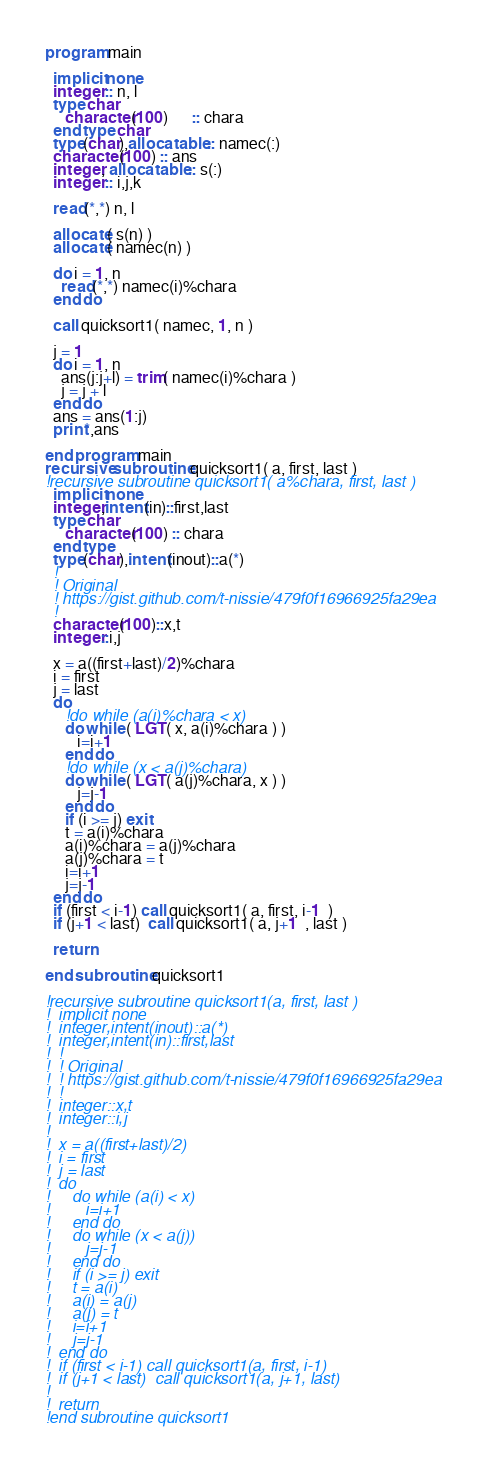<code> <loc_0><loc_0><loc_500><loc_500><_FORTRAN_>program main
  
  implicit none
  integer :: n, l
  type char
     character(100)      :: chara
  end type char
  type(char),allocatable :: namec(:)
  character(100) :: ans
  integer, allocatable :: s(:)
  integer :: i,j,k
  
  read(*,*) n, l

  allocate( s(n) )
  allocate( namec(n) )

  do i = 1, n
    read(*,*) namec(i)%chara
  end do

  call quicksort1( namec, 1, n ) 
  
  j = 1
  do i = 1, n
    ans(j:j+l) = trim( namec(i)%chara )
    j = j + l 
  end do
  ans = ans(1:j)
  print*,ans

end program main
recursive subroutine quicksort1( a, first, last )
!recursive subroutine quicksort1( a%chara, first, last )
  implicit none
  integer,intent(in)::first,last
  type char
     character(100) :: chara 
  end type 
  type(char),intent(inout)::a(*)
  !
  ! Original
  ! https://gist.github.com/t-nissie/479f0f16966925fa29ea
  !
  character(100)::x,t
  integer::i,j

  x = a((first+last)/2)%chara
  i = first
  j = last
  do
     !do while (a(i)%chara < x)
     do while ( LGT( x, a(i)%chara ) )
        i=i+1
     end do
     !do while (x < a(j)%chara)
     do while ( LGT( a(j)%chara, x ) )
        j=j-1
     end do
     if (i >= j) exit
     t = a(i)%chara
     a(i)%chara = a(j)%chara
     a(j)%chara = t
     i=i+1
     j=j-1
  end do
  if (first < i-1) call quicksort1( a, first, i-1  )
  if (j+1 < last)  call quicksort1( a, j+1  , last )

  return

end subroutine quicksort1

!recursive subroutine quicksort1(a, first, last )
!  implicit none
!  integer,intent(inout)::a(*)
!  integer,intent(in)::first,last
!  !
!  ! Original
!  ! https://gist.github.com/t-nissie/479f0f16966925fa29ea
!  !
!  integer::x,t
!  integer::i,j
!
!  x = a((first+last)/2)
!  i = first
!  j = last
!  do
!     do while (a(i) < x)
!        i=i+1
!     end do
!     do while (x < a(j))
!        j=j-1
!     end do
!     if (i >= j) exit
!     t = a(i)
!     a(i) = a(j)
!     a(j) = t
!     i=i+1
!     j=j-1
!  end do
!  if (first < i-1) call quicksort1(a, first, i-1)
!  if (j+1 < last)  call quicksort1(a, j+1, last)
!
!  return
!end subroutine quicksort1

</code> 